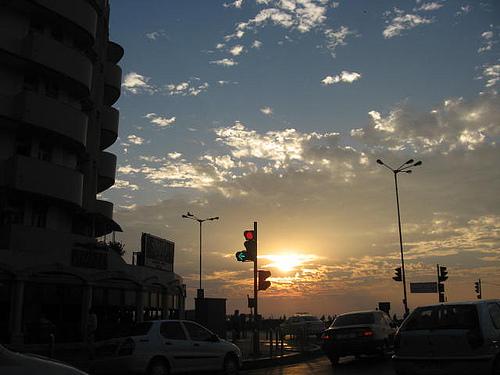Can you see any cars?
Keep it brief. Yes. What time of day is this?
Answer briefly. Dusk. How many lightbulbs does it take to fill each lamp post?
Give a very brief answer. 4. 